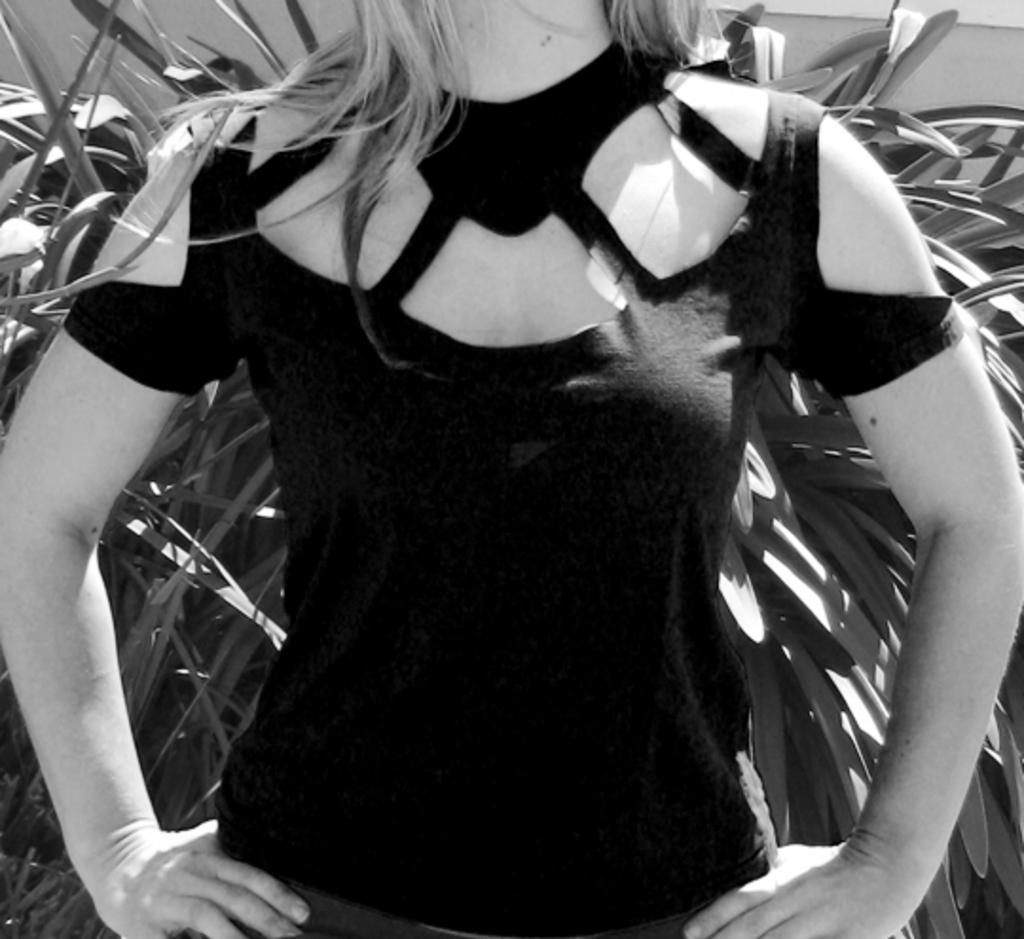What is the color scheme of the image? The image is black and white. Can you describe the main subject of the image? There is a woman without a head in the image. What can be seen in the background of the image? There are plants in the background of the image. What type of goat can be seen playing with an icicle in the image? There is no goat or icicle present in the image; it features a woman without a head and plants in the background. 